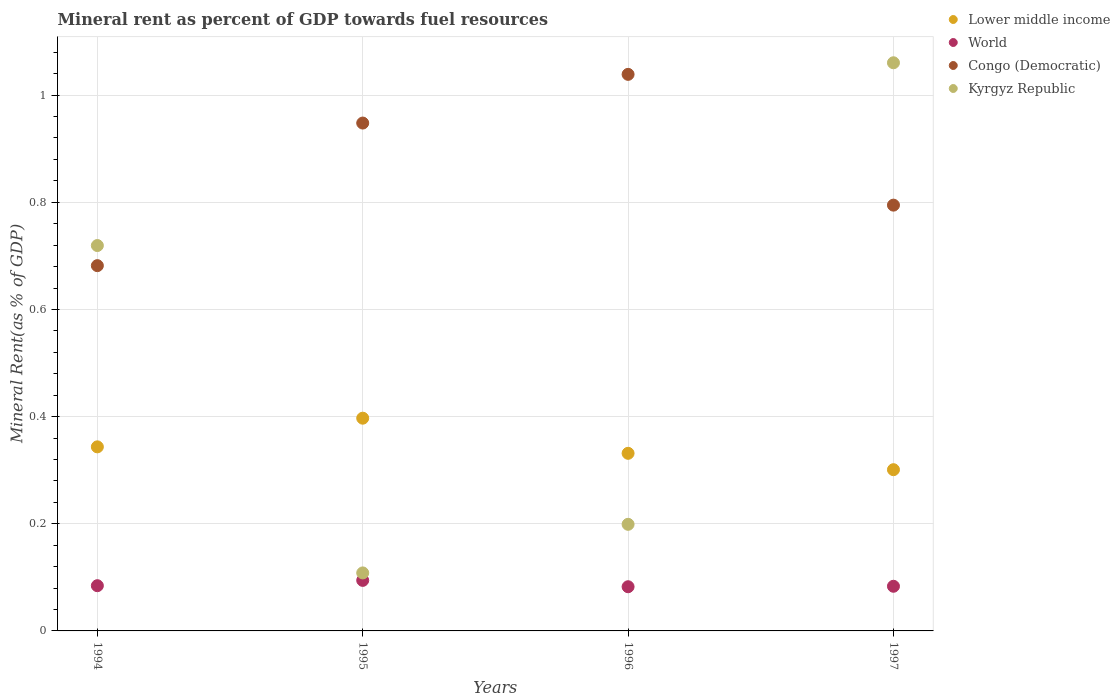Is the number of dotlines equal to the number of legend labels?
Give a very brief answer. Yes. What is the mineral rent in Congo (Democratic) in 1997?
Your answer should be compact. 0.79. Across all years, what is the maximum mineral rent in Lower middle income?
Keep it short and to the point. 0.4. Across all years, what is the minimum mineral rent in Congo (Democratic)?
Offer a very short reply. 0.68. What is the total mineral rent in World in the graph?
Your response must be concise. 0.34. What is the difference between the mineral rent in Congo (Democratic) in 1995 and that in 1996?
Offer a terse response. -0.09. What is the difference between the mineral rent in Lower middle income in 1994 and the mineral rent in Kyrgyz Republic in 1996?
Provide a short and direct response. 0.14. What is the average mineral rent in Kyrgyz Republic per year?
Offer a terse response. 0.52. In the year 1997, what is the difference between the mineral rent in Congo (Democratic) and mineral rent in Kyrgyz Republic?
Your answer should be compact. -0.27. In how many years, is the mineral rent in World greater than 0.08 %?
Make the answer very short. 4. What is the ratio of the mineral rent in Lower middle income in 1994 to that in 1997?
Keep it short and to the point. 1.14. What is the difference between the highest and the second highest mineral rent in Lower middle income?
Your answer should be compact. 0.05. What is the difference between the highest and the lowest mineral rent in Congo (Democratic)?
Provide a succinct answer. 0.36. Is the sum of the mineral rent in World in 1995 and 1996 greater than the maximum mineral rent in Lower middle income across all years?
Your answer should be compact. No. Is it the case that in every year, the sum of the mineral rent in Congo (Democratic) and mineral rent in Kyrgyz Republic  is greater than the mineral rent in Lower middle income?
Keep it short and to the point. Yes. Does the mineral rent in Lower middle income monotonically increase over the years?
Your answer should be compact. No. Is the mineral rent in Kyrgyz Republic strictly greater than the mineral rent in Lower middle income over the years?
Offer a terse response. No. How many dotlines are there?
Provide a succinct answer. 4. Does the graph contain any zero values?
Your answer should be compact. No. Does the graph contain grids?
Give a very brief answer. Yes. What is the title of the graph?
Provide a succinct answer. Mineral rent as percent of GDP towards fuel resources. What is the label or title of the X-axis?
Make the answer very short. Years. What is the label or title of the Y-axis?
Provide a succinct answer. Mineral Rent(as % of GDP). What is the Mineral Rent(as % of GDP) of Lower middle income in 1994?
Ensure brevity in your answer.  0.34. What is the Mineral Rent(as % of GDP) of World in 1994?
Give a very brief answer. 0.08. What is the Mineral Rent(as % of GDP) in Congo (Democratic) in 1994?
Keep it short and to the point. 0.68. What is the Mineral Rent(as % of GDP) of Kyrgyz Republic in 1994?
Your answer should be very brief. 0.72. What is the Mineral Rent(as % of GDP) in Lower middle income in 1995?
Your response must be concise. 0.4. What is the Mineral Rent(as % of GDP) of World in 1995?
Offer a terse response. 0.09. What is the Mineral Rent(as % of GDP) of Congo (Democratic) in 1995?
Make the answer very short. 0.95. What is the Mineral Rent(as % of GDP) in Kyrgyz Republic in 1995?
Ensure brevity in your answer.  0.11. What is the Mineral Rent(as % of GDP) in Lower middle income in 1996?
Your answer should be very brief. 0.33. What is the Mineral Rent(as % of GDP) of World in 1996?
Your answer should be compact. 0.08. What is the Mineral Rent(as % of GDP) in Congo (Democratic) in 1996?
Your answer should be compact. 1.04. What is the Mineral Rent(as % of GDP) in Kyrgyz Republic in 1996?
Provide a short and direct response. 0.2. What is the Mineral Rent(as % of GDP) in Lower middle income in 1997?
Your answer should be very brief. 0.3. What is the Mineral Rent(as % of GDP) of World in 1997?
Offer a very short reply. 0.08. What is the Mineral Rent(as % of GDP) in Congo (Democratic) in 1997?
Offer a terse response. 0.79. What is the Mineral Rent(as % of GDP) in Kyrgyz Republic in 1997?
Your answer should be very brief. 1.06. Across all years, what is the maximum Mineral Rent(as % of GDP) in Lower middle income?
Give a very brief answer. 0.4. Across all years, what is the maximum Mineral Rent(as % of GDP) of World?
Make the answer very short. 0.09. Across all years, what is the maximum Mineral Rent(as % of GDP) in Congo (Democratic)?
Make the answer very short. 1.04. Across all years, what is the maximum Mineral Rent(as % of GDP) of Kyrgyz Republic?
Offer a very short reply. 1.06. Across all years, what is the minimum Mineral Rent(as % of GDP) of Lower middle income?
Offer a terse response. 0.3. Across all years, what is the minimum Mineral Rent(as % of GDP) of World?
Keep it short and to the point. 0.08. Across all years, what is the minimum Mineral Rent(as % of GDP) in Congo (Democratic)?
Offer a very short reply. 0.68. Across all years, what is the minimum Mineral Rent(as % of GDP) in Kyrgyz Republic?
Give a very brief answer. 0.11. What is the total Mineral Rent(as % of GDP) in Lower middle income in the graph?
Keep it short and to the point. 1.37. What is the total Mineral Rent(as % of GDP) in World in the graph?
Your answer should be very brief. 0.34. What is the total Mineral Rent(as % of GDP) of Congo (Democratic) in the graph?
Provide a succinct answer. 3.46. What is the total Mineral Rent(as % of GDP) in Kyrgyz Republic in the graph?
Ensure brevity in your answer.  2.09. What is the difference between the Mineral Rent(as % of GDP) of Lower middle income in 1994 and that in 1995?
Keep it short and to the point. -0.05. What is the difference between the Mineral Rent(as % of GDP) of World in 1994 and that in 1995?
Keep it short and to the point. -0.01. What is the difference between the Mineral Rent(as % of GDP) of Congo (Democratic) in 1994 and that in 1995?
Ensure brevity in your answer.  -0.27. What is the difference between the Mineral Rent(as % of GDP) of Kyrgyz Republic in 1994 and that in 1995?
Your answer should be compact. 0.61. What is the difference between the Mineral Rent(as % of GDP) in Lower middle income in 1994 and that in 1996?
Your answer should be compact. 0.01. What is the difference between the Mineral Rent(as % of GDP) in World in 1994 and that in 1996?
Offer a terse response. 0. What is the difference between the Mineral Rent(as % of GDP) of Congo (Democratic) in 1994 and that in 1996?
Your response must be concise. -0.36. What is the difference between the Mineral Rent(as % of GDP) in Kyrgyz Republic in 1994 and that in 1996?
Ensure brevity in your answer.  0.52. What is the difference between the Mineral Rent(as % of GDP) of Lower middle income in 1994 and that in 1997?
Make the answer very short. 0.04. What is the difference between the Mineral Rent(as % of GDP) in World in 1994 and that in 1997?
Keep it short and to the point. 0. What is the difference between the Mineral Rent(as % of GDP) of Congo (Democratic) in 1994 and that in 1997?
Ensure brevity in your answer.  -0.11. What is the difference between the Mineral Rent(as % of GDP) in Kyrgyz Republic in 1994 and that in 1997?
Provide a short and direct response. -0.34. What is the difference between the Mineral Rent(as % of GDP) in Lower middle income in 1995 and that in 1996?
Your answer should be very brief. 0.07. What is the difference between the Mineral Rent(as % of GDP) of World in 1995 and that in 1996?
Your response must be concise. 0.01. What is the difference between the Mineral Rent(as % of GDP) in Congo (Democratic) in 1995 and that in 1996?
Ensure brevity in your answer.  -0.09. What is the difference between the Mineral Rent(as % of GDP) in Kyrgyz Republic in 1995 and that in 1996?
Make the answer very short. -0.09. What is the difference between the Mineral Rent(as % of GDP) of Lower middle income in 1995 and that in 1997?
Provide a succinct answer. 0.1. What is the difference between the Mineral Rent(as % of GDP) of World in 1995 and that in 1997?
Keep it short and to the point. 0.01. What is the difference between the Mineral Rent(as % of GDP) in Congo (Democratic) in 1995 and that in 1997?
Your answer should be very brief. 0.15. What is the difference between the Mineral Rent(as % of GDP) in Kyrgyz Republic in 1995 and that in 1997?
Your answer should be compact. -0.95. What is the difference between the Mineral Rent(as % of GDP) of Lower middle income in 1996 and that in 1997?
Ensure brevity in your answer.  0.03. What is the difference between the Mineral Rent(as % of GDP) of World in 1996 and that in 1997?
Make the answer very short. -0. What is the difference between the Mineral Rent(as % of GDP) in Congo (Democratic) in 1996 and that in 1997?
Your response must be concise. 0.24. What is the difference between the Mineral Rent(as % of GDP) in Kyrgyz Republic in 1996 and that in 1997?
Ensure brevity in your answer.  -0.86. What is the difference between the Mineral Rent(as % of GDP) in Lower middle income in 1994 and the Mineral Rent(as % of GDP) in World in 1995?
Provide a short and direct response. 0.25. What is the difference between the Mineral Rent(as % of GDP) in Lower middle income in 1994 and the Mineral Rent(as % of GDP) in Congo (Democratic) in 1995?
Provide a short and direct response. -0.6. What is the difference between the Mineral Rent(as % of GDP) in Lower middle income in 1994 and the Mineral Rent(as % of GDP) in Kyrgyz Republic in 1995?
Your response must be concise. 0.24. What is the difference between the Mineral Rent(as % of GDP) in World in 1994 and the Mineral Rent(as % of GDP) in Congo (Democratic) in 1995?
Your answer should be very brief. -0.86. What is the difference between the Mineral Rent(as % of GDP) of World in 1994 and the Mineral Rent(as % of GDP) of Kyrgyz Republic in 1995?
Offer a very short reply. -0.02. What is the difference between the Mineral Rent(as % of GDP) of Congo (Democratic) in 1994 and the Mineral Rent(as % of GDP) of Kyrgyz Republic in 1995?
Offer a terse response. 0.57. What is the difference between the Mineral Rent(as % of GDP) of Lower middle income in 1994 and the Mineral Rent(as % of GDP) of World in 1996?
Keep it short and to the point. 0.26. What is the difference between the Mineral Rent(as % of GDP) of Lower middle income in 1994 and the Mineral Rent(as % of GDP) of Congo (Democratic) in 1996?
Provide a succinct answer. -0.7. What is the difference between the Mineral Rent(as % of GDP) of Lower middle income in 1994 and the Mineral Rent(as % of GDP) of Kyrgyz Republic in 1996?
Offer a very short reply. 0.14. What is the difference between the Mineral Rent(as % of GDP) in World in 1994 and the Mineral Rent(as % of GDP) in Congo (Democratic) in 1996?
Your answer should be very brief. -0.95. What is the difference between the Mineral Rent(as % of GDP) in World in 1994 and the Mineral Rent(as % of GDP) in Kyrgyz Republic in 1996?
Make the answer very short. -0.11. What is the difference between the Mineral Rent(as % of GDP) in Congo (Democratic) in 1994 and the Mineral Rent(as % of GDP) in Kyrgyz Republic in 1996?
Give a very brief answer. 0.48. What is the difference between the Mineral Rent(as % of GDP) of Lower middle income in 1994 and the Mineral Rent(as % of GDP) of World in 1997?
Your answer should be very brief. 0.26. What is the difference between the Mineral Rent(as % of GDP) in Lower middle income in 1994 and the Mineral Rent(as % of GDP) in Congo (Democratic) in 1997?
Keep it short and to the point. -0.45. What is the difference between the Mineral Rent(as % of GDP) of Lower middle income in 1994 and the Mineral Rent(as % of GDP) of Kyrgyz Republic in 1997?
Ensure brevity in your answer.  -0.72. What is the difference between the Mineral Rent(as % of GDP) of World in 1994 and the Mineral Rent(as % of GDP) of Congo (Democratic) in 1997?
Your response must be concise. -0.71. What is the difference between the Mineral Rent(as % of GDP) of World in 1994 and the Mineral Rent(as % of GDP) of Kyrgyz Republic in 1997?
Give a very brief answer. -0.98. What is the difference between the Mineral Rent(as % of GDP) in Congo (Democratic) in 1994 and the Mineral Rent(as % of GDP) in Kyrgyz Republic in 1997?
Make the answer very short. -0.38. What is the difference between the Mineral Rent(as % of GDP) in Lower middle income in 1995 and the Mineral Rent(as % of GDP) in World in 1996?
Give a very brief answer. 0.31. What is the difference between the Mineral Rent(as % of GDP) of Lower middle income in 1995 and the Mineral Rent(as % of GDP) of Congo (Democratic) in 1996?
Your answer should be very brief. -0.64. What is the difference between the Mineral Rent(as % of GDP) of Lower middle income in 1995 and the Mineral Rent(as % of GDP) of Kyrgyz Republic in 1996?
Make the answer very short. 0.2. What is the difference between the Mineral Rent(as % of GDP) in World in 1995 and the Mineral Rent(as % of GDP) in Congo (Democratic) in 1996?
Offer a very short reply. -0.94. What is the difference between the Mineral Rent(as % of GDP) of World in 1995 and the Mineral Rent(as % of GDP) of Kyrgyz Republic in 1996?
Provide a short and direct response. -0.1. What is the difference between the Mineral Rent(as % of GDP) in Congo (Democratic) in 1995 and the Mineral Rent(as % of GDP) in Kyrgyz Republic in 1996?
Ensure brevity in your answer.  0.75. What is the difference between the Mineral Rent(as % of GDP) of Lower middle income in 1995 and the Mineral Rent(as % of GDP) of World in 1997?
Keep it short and to the point. 0.31. What is the difference between the Mineral Rent(as % of GDP) of Lower middle income in 1995 and the Mineral Rent(as % of GDP) of Congo (Democratic) in 1997?
Ensure brevity in your answer.  -0.4. What is the difference between the Mineral Rent(as % of GDP) of Lower middle income in 1995 and the Mineral Rent(as % of GDP) of Kyrgyz Republic in 1997?
Provide a short and direct response. -0.66. What is the difference between the Mineral Rent(as % of GDP) of World in 1995 and the Mineral Rent(as % of GDP) of Congo (Democratic) in 1997?
Ensure brevity in your answer.  -0.7. What is the difference between the Mineral Rent(as % of GDP) in World in 1995 and the Mineral Rent(as % of GDP) in Kyrgyz Republic in 1997?
Ensure brevity in your answer.  -0.97. What is the difference between the Mineral Rent(as % of GDP) in Congo (Democratic) in 1995 and the Mineral Rent(as % of GDP) in Kyrgyz Republic in 1997?
Provide a succinct answer. -0.11. What is the difference between the Mineral Rent(as % of GDP) in Lower middle income in 1996 and the Mineral Rent(as % of GDP) in World in 1997?
Ensure brevity in your answer.  0.25. What is the difference between the Mineral Rent(as % of GDP) in Lower middle income in 1996 and the Mineral Rent(as % of GDP) in Congo (Democratic) in 1997?
Your answer should be compact. -0.46. What is the difference between the Mineral Rent(as % of GDP) in Lower middle income in 1996 and the Mineral Rent(as % of GDP) in Kyrgyz Republic in 1997?
Your response must be concise. -0.73. What is the difference between the Mineral Rent(as % of GDP) of World in 1996 and the Mineral Rent(as % of GDP) of Congo (Democratic) in 1997?
Keep it short and to the point. -0.71. What is the difference between the Mineral Rent(as % of GDP) of World in 1996 and the Mineral Rent(as % of GDP) of Kyrgyz Republic in 1997?
Ensure brevity in your answer.  -0.98. What is the difference between the Mineral Rent(as % of GDP) in Congo (Democratic) in 1996 and the Mineral Rent(as % of GDP) in Kyrgyz Republic in 1997?
Ensure brevity in your answer.  -0.02. What is the average Mineral Rent(as % of GDP) of Lower middle income per year?
Ensure brevity in your answer.  0.34. What is the average Mineral Rent(as % of GDP) in World per year?
Offer a very short reply. 0.09. What is the average Mineral Rent(as % of GDP) in Congo (Democratic) per year?
Your answer should be compact. 0.87. What is the average Mineral Rent(as % of GDP) in Kyrgyz Republic per year?
Make the answer very short. 0.52. In the year 1994, what is the difference between the Mineral Rent(as % of GDP) of Lower middle income and Mineral Rent(as % of GDP) of World?
Provide a succinct answer. 0.26. In the year 1994, what is the difference between the Mineral Rent(as % of GDP) in Lower middle income and Mineral Rent(as % of GDP) in Congo (Democratic)?
Offer a terse response. -0.34. In the year 1994, what is the difference between the Mineral Rent(as % of GDP) of Lower middle income and Mineral Rent(as % of GDP) of Kyrgyz Republic?
Your response must be concise. -0.38. In the year 1994, what is the difference between the Mineral Rent(as % of GDP) of World and Mineral Rent(as % of GDP) of Congo (Democratic)?
Provide a short and direct response. -0.6. In the year 1994, what is the difference between the Mineral Rent(as % of GDP) of World and Mineral Rent(as % of GDP) of Kyrgyz Republic?
Ensure brevity in your answer.  -0.63. In the year 1994, what is the difference between the Mineral Rent(as % of GDP) in Congo (Democratic) and Mineral Rent(as % of GDP) in Kyrgyz Republic?
Make the answer very short. -0.04. In the year 1995, what is the difference between the Mineral Rent(as % of GDP) in Lower middle income and Mineral Rent(as % of GDP) in World?
Give a very brief answer. 0.3. In the year 1995, what is the difference between the Mineral Rent(as % of GDP) in Lower middle income and Mineral Rent(as % of GDP) in Congo (Democratic)?
Give a very brief answer. -0.55. In the year 1995, what is the difference between the Mineral Rent(as % of GDP) of Lower middle income and Mineral Rent(as % of GDP) of Kyrgyz Republic?
Your answer should be compact. 0.29. In the year 1995, what is the difference between the Mineral Rent(as % of GDP) of World and Mineral Rent(as % of GDP) of Congo (Democratic)?
Your response must be concise. -0.85. In the year 1995, what is the difference between the Mineral Rent(as % of GDP) of World and Mineral Rent(as % of GDP) of Kyrgyz Republic?
Provide a succinct answer. -0.01. In the year 1995, what is the difference between the Mineral Rent(as % of GDP) in Congo (Democratic) and Mineral Rent(as % of GDP) in Kyrgyz Republic?
Your response must be concise. 0.84. In the year 1996, what is the difference between the Mineral Rent(as % of GDP) of Lower middle income and Mineral Rent(as % of GDP) of World?
Provide a succinct answer. 0.25. In the year 1996, what is the difference between the Mineral Rent(as % of GDP) of Lower middle income and Mineral Rent(as % of GDP) of Congo (Democratic)?
Offer a terse response. -0.71. In the year 1996, what is the difference between the Mineral Rent(as % of GDP) in Lower middle income and Mineral Rent(as % of GDP) in Kyrgyz Republic?
Give a very brief answer. 0.13. In the year 1996, what is the difference between the Mineral Rent(as % of GDP) of World and Mineral Rent(as % of GDP) of Congo (Democratic)?
Provide a short and direct response. -0.96. In the year 1996, what is the difference between the Mineral Rent(as % of GDP) in World and Mineral Rent(as % of GDP) in Kyrgyz Republic?
Provide a succinct answer. -0.12. In the year 1996, what is the difference between the Mineral Rent(as % of GDP) of Congo (Democratic) and Mineral Rent(as % of GDP) of Kyrgyz Republic?
Ensure brevity in your answer.  0.84. In the year 1997, what is the difference between the Mineral Rent(as % of GDP) in Lower middle income and Mineral Rent(as % of GDP) in World?
Offer a terse response. 0.22. In the year 1997, what is the difference between the Mineral Rent(as % of GDP) in Lower middle income and Mineral Rent(as % of GDP) in Congo (Democratic)?
Offer a very short reply. -0.49. In the year 1997, what is the difference between the Mineral Rent(as % of GDP) of Lower middle income and Mineral Rent(as % of GDP) of Kyrgyz Republic?
Keep it short and to the point. -0.76. In the year 1997, what is the difference between the Mineral Rent(as % of GDP) in World and Mineral Rent(as % of GDP) in Congo (Democratic)?
Keep it short and to the point. -0.71. In the year 1997, what is the difference between the Mineral Rent(as % of GDP) in World and Mineral Rent(as % of GDP) in Kyrgyz Republic?
Ensure brevity in your answer.  -0.98. In the year 1997, what is the difference between the Mineral Rent(as % of GDP) of Congo (Democratic) and Mineral Rent(as % of GDP) of Kyrgyz Republic?
Make the answer very short. -0.27. What is the ratio of the Mineral Rent(as % of GDP) of Lower middle income in 1994 to that in 1995?
Your answer should be very brief. 0.87. What is the ratio of the Mineral Rent(as % of GDP) in World in 1994 to that in 1995?
Give a very brief answer. 0.89. What is the ratio of the Mineral Rent(as % of GDP) in Congo (Democratic) in 1994 to that in 1995?
Make the answer very short. 0.72. What is the ratio of the Mineral Rent(as % of GDP) in Kyrgyz Republic in 1994 to that in 1995?
Your answer should be compact. 6.64. What is the ratio of the Mineral Rent(as % of GDP) in Lower middle income in 1994 to that in 1996?
Ensure brevity in your answer.  1.04. What is the ratio of the Mineral Rent(as % of GDP) in World in 1994 to that in 1996?
Keep it short and to the point. 1.02. What is the ratio of the Mineral Rent(as % of GDP) of Congo (Democratic) in 1994 to that in 1996?
Your answer should be very brief. 0.66. What is the ratio of the Mineral Rent(as % of GDP) in Kyrgyz Republic in 1994 to that in 1996?
Offer a terse response. 3.61. What is the ratio of the Mineral Rent(as % of GDP) in Lower middle income in 1994 to that in 1997?
Keep it short and to the point. 1.14. What is the ratio of the Mineral Rent(as % of GDP) in World in 1994 to that in 1997?
Provide a succinct answer. 1.01. What is the ratio of the Mineral Rent(as % of GDP) of Congo (Democratic) in 1994 to that in 1997?
Keep it short and to the point. 0.86. What is the ratio of the Mineral Rent(as % of GDP) in Kyrgyz Republic in 1994 to that in 1997?
Keep it short and to the point. 0.68. What is the ratio of the Mineral Rent(as % of GDP) of Lower middle income in 1995 to that in 1996?
Provide a short and direct response. 1.2. What is the ratio of the Mineral Rent(as % of GDP) of World in 1995 to that in 1996?
Ensure brevity in your answer.  1.14. What is the ratio of the Mineral Rent(as % of GDP) of Congo (Democratic) in 1995 to that in 1996?
Make the answer very short. 0.91. What is the ratio of the Mineral Rent(as % of GDP) of Kyrgyz Republic in 1995 to that in 1996?
Your answer should be compact. 0.54. What is the ratio of the Mineral Rent(as % of GDP) in Lower middle income in 1995 to that in 1997?
Keep it short and to the point. 1.32. What is the ratio of the Mineral Rent(as % of GDP) in World in 1995 to that in 1997?
Ensure brevity in your answer.  1.13. What is the ratio of the Mineral Rent(as % of GDP) in Congo (Democratic) in 1995 to that in 1997?
Keep it short and to the point. 1.19. What is the ratio of the Mineral Rent(as % of GDP) of Kyrgyz Republic in 1995 to that in 1997?
Your answer should be compact. 0.1. What is the ratio of the Mineral Rent(as % of GDP) of Lower middle income in 1996 to that in 1997?
Keep it short and to the point. 1.1. What is the ratio of the Mineral Rent(as % of GDP) in World in 1996 to that in 1997?
Offer a very short reply. 0.99. What is the ratio of the Mineral Rent(as % of GDP) in Congo (Democratic) in 1996 to that in 1997?
Make the answer very short. 1.31. What is the ratio of the Mineral Rent(as % of GDP) in Kyrgyz Republic in 1996 to that in 1997?
Your answer should be compact. 0.19. What is the difference between the highest and the second highest Mineral Rent(as % of GDP) in Lower middle income?
Your answer should be very brief. 0.05. What is the difference between the highest and the second highest Mineral Rent(as % of GDP) of World?
Give a very brief answer. 0.01. What is the difference between the highest and the second highest Mineral Rent(as % of GDP) in Congo (Democratic)?
Ensure brevity in your answer.  0.09. What is the difference between the highest and the second highest Mineral Rent(as % of GDP) of Kyrgyz Republic?
Offer a very short reply. 0.34. What is the difference between the highest and the lowest Mineral Rent(as % of GDP) of Lower middle income?
Provide a succinct answer. 0.1. What is the difference between the highest and the lowest Mineral Rent(as % of GDP) of World?
Your answer should be compact. 0.01. What is the difference between the highest and the lowest Mineral Rent(as % of GDP) in Congo (Democratic)?
Ensure brevity in your answer.  0.36. What is the difference between the highest and the lowest Mineral Rent(as % of GDP) in Kyrgyz Republic?
Offer a terse response. 0.95. 